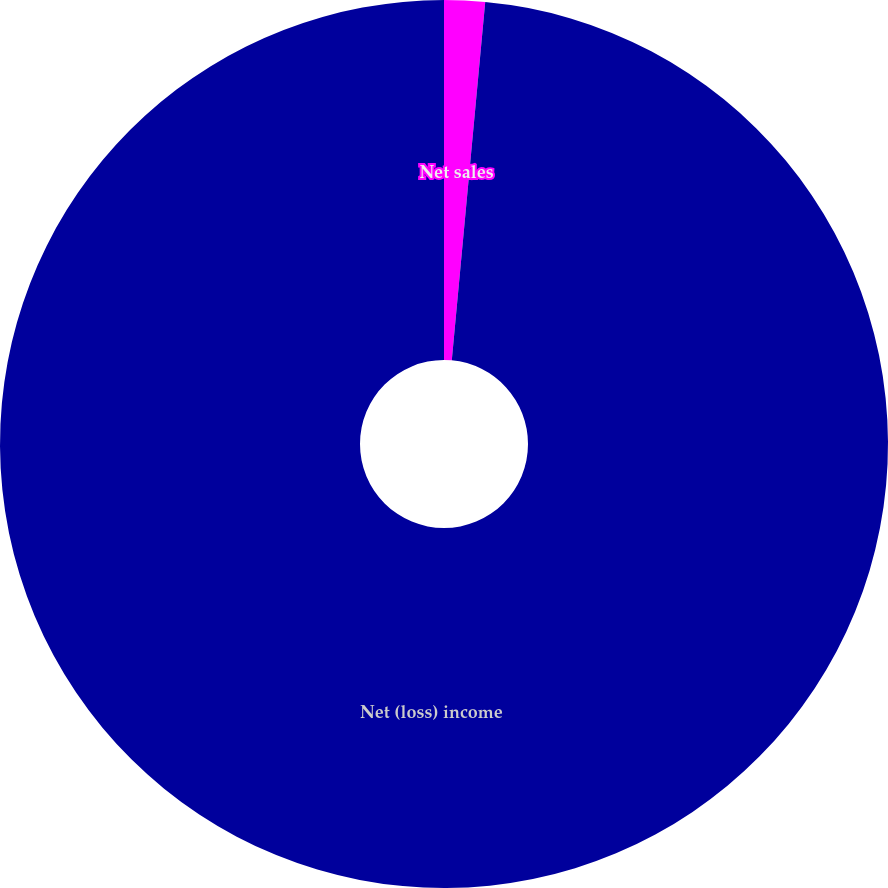Convert chart. <chart><loc_0><loc_0><loc_500><loc_500><pie_chart><fcel>Net sales<fcel>Net (loss) income<nl><fcel>1.48%<fcel>98.52%<nl></chart> 